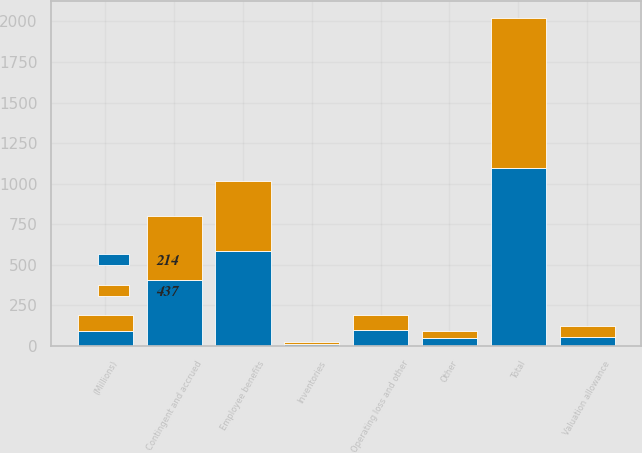Convert chart to OTSL. <chart><loc_0><loc_0><loc_500><loc_500><stacked_bar_chart><ecel><fcel>(Millions)<fcel>Employee benefits<fcel>Contingent and accrued<fcel>Operating loss and other<fcel>Inventories<fcel>Other<fcel>Valuation allowance<fcel>Total<nl><fcel>214<fcel>94<fcel>584<fcel>409<fcel>96<fcel>11<fcel>50<fcel>58<fcel>1097<nl><fcel>437<fcel>94<fcel>431<fcel>391<fcel>92<fcel>16<fcel>40<fcel>63<fcel>925<nl></chart> 